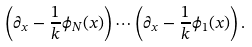<formula> <loc_0><loc_0><loc_500><loc_500>\left ( \partial _ { x } - \frac { 1 } { k } \phi _ { N } ( x ) \right ) \cdots \left ( \partial _ { x } - \frac { 1 } { k } \phi _ { 1 } ( x ) \right ) .</formula> 